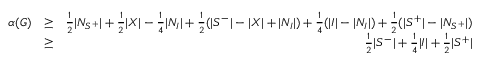<formula> <loc_0><loc_0><loc_500><loc_500>\begin{array} { r l r } { \alpha ( G ) } & { \geq } & { \frac { 1 } { 2 } | N _ { S ^ { + } } | + \frac { 1 } { 2 } | X | - \frac { 1 } { 4 } | N _ { I } | + \frac { 1 } { 2 } ( | S ^ { - } | - | X | + | N _ { I } | ) + \frac { 1 } { 4 } ( | I | - | N _ { I } | ) + \frac { 1 } { 2 } ( | S ^ { + } | - | N _ { S ^ { + } } | ) } \\ & { \geq } & { \frac { 1 } { 2 } | S ^ { - } | + \frac { 1 } { 4 } | I | + \frac { 1 } { 2 } | S ^ { + } | } \end{array}</formula> 